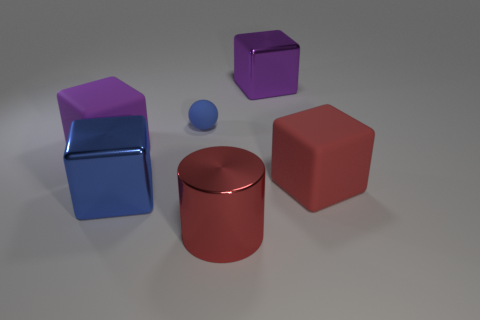Are there more tiny cyan metal spheres than matte balls?
Keep it short and to the point. No. How many other objects are there of the same color as the tiny rubber thing?
Give a very brief answer. 1. How many objects are on the left side of the red rubber thing and behind the big blue shiny thing?
Your answer should be very brief. 3. Are there any other things that have the same size as the blue shiny object?
Your answer should be compact. Yes. Are there more purple metallic things on the left side of the tiny rubber object than red objects behind the blue metal object?
Offer a terse response. No. There is a large purple block to the left of the red cylinder; what is its material?
Give a very brief answer. Rubber. Is the shape of the blue matte object the same as the large metal thing that is behind the purple rubber cube?
Your response must be concise. No. What number of big blocks are behind the large red thing on the right side of the metallic cube that is behind the large red cube?
Your answer should be compact. 2. What color is the other big matte thing that is the same shape as the large purple matte thing?
Your response must be concise. Red. Is there anything else that has the same shape as the red rubber object?
Your answer should be very brief. Yes. 